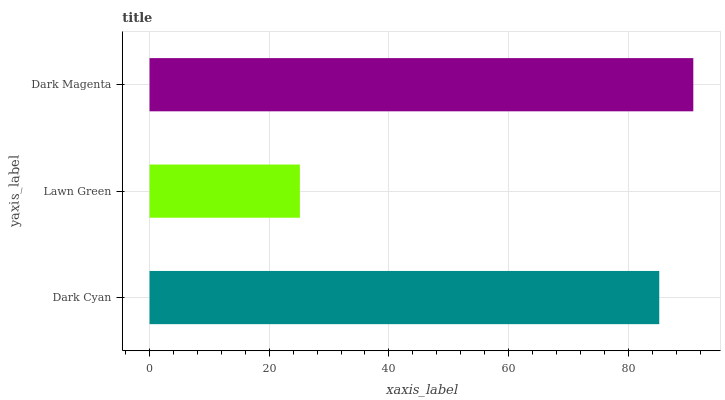Is Lawn Green the minimum?
Answer yes or no. Yes. Is Dark Magenta the maximum?
Answer yes or no. Yes. Is Dark Magenta the minimum?
Answer yes or no. No. Is Lawn Green the maximum?
Answer yes or no. No. Is Dark Magenta greater than Lawn Green?
Answer yes or no. Yes. Is Lawn Green less than Dark Magenta?
Answer yes or no. Yes. Is Lawn Green greater than Dark Magenta?
Answer yes or no. No. Is Dark Magenta less than Lawn Green?
Answer yes or no. No. Is Dark Cyan the high median?
Answer yes or no. Yes. Is Dark Cyan the low median?
Answer yes or no. Yes. Is Dark Magenta the high median?
Answer yes or no. No. Is Lawn Green the low median?
Answer yes or no. No. 